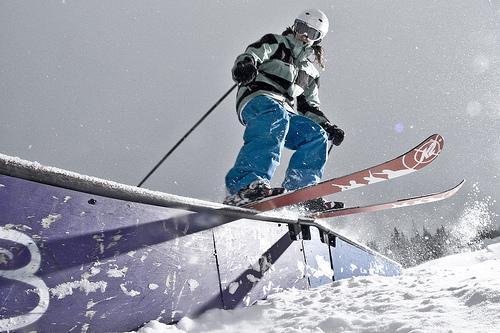How many skiers are in the picture?
Give a very brief answer. 1. 